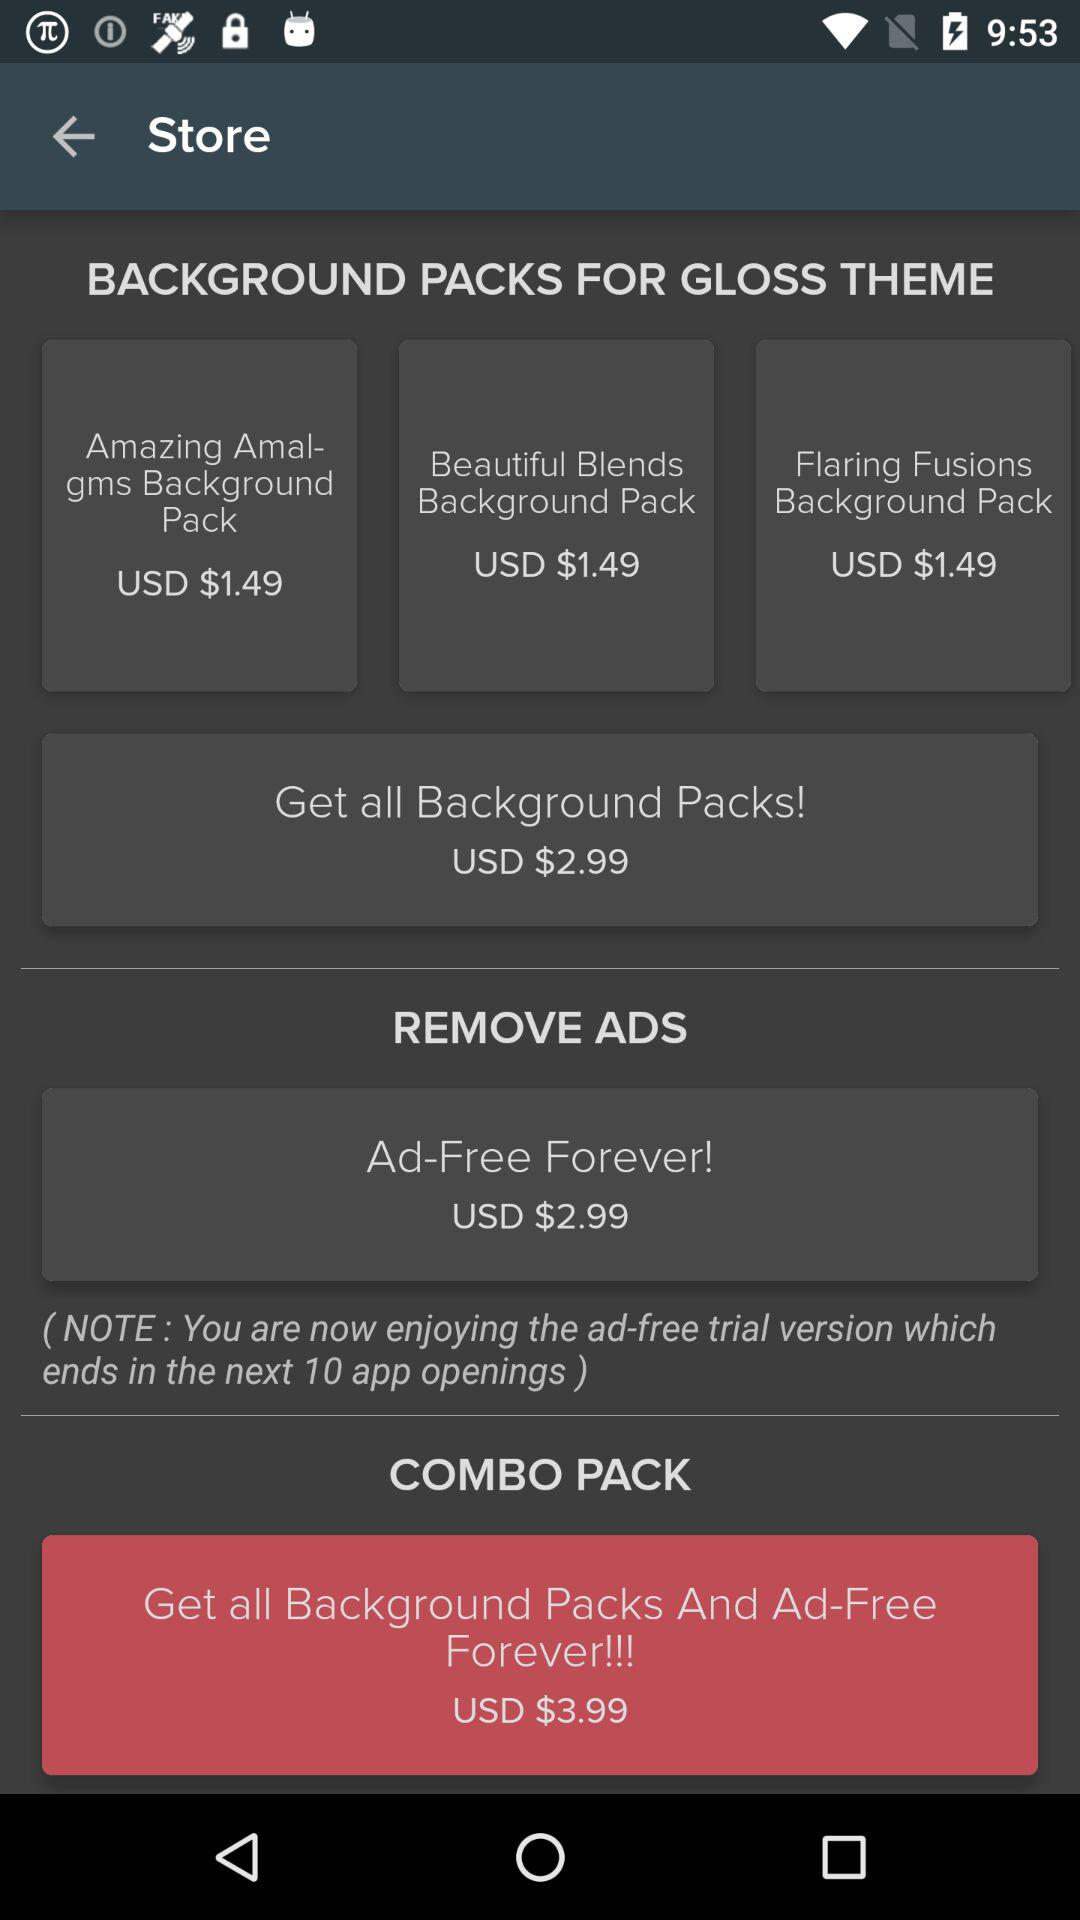What is the price of the "Beautiful Blended Background Pack"? The price of the "Beautiful Blended Background Pack" is USD $1.49. 